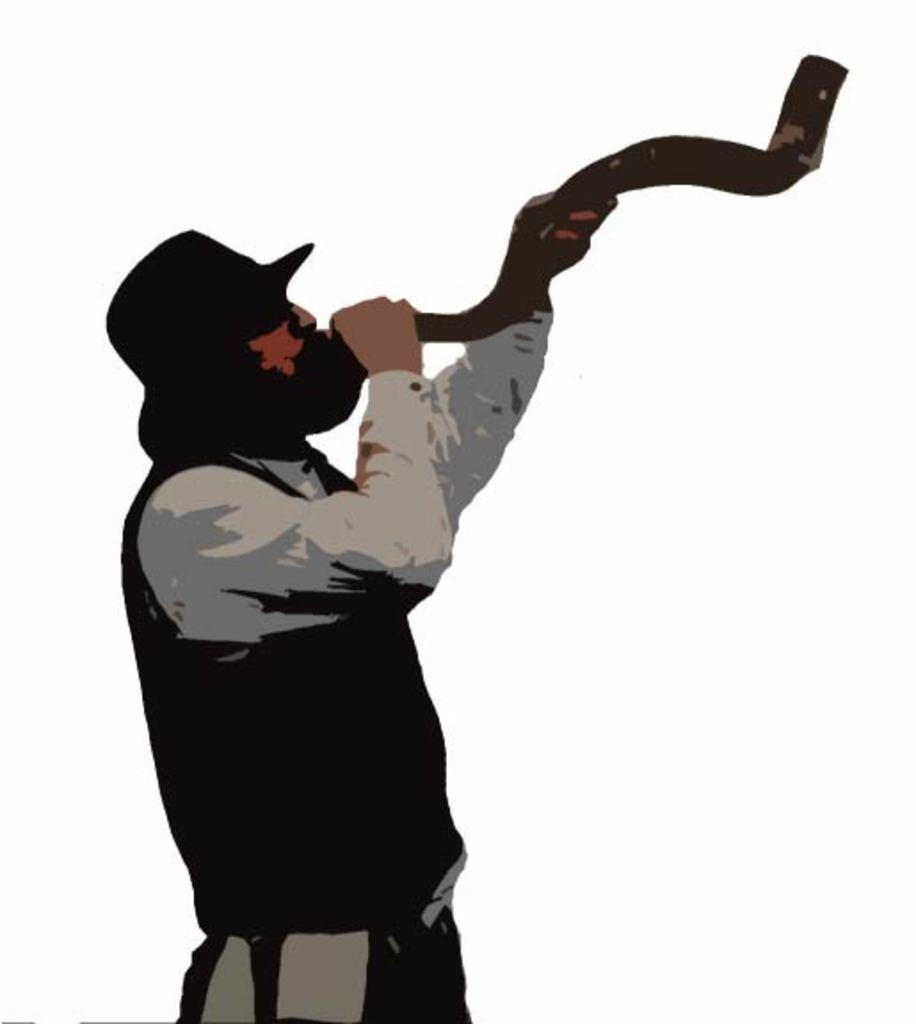Please provide a concise description of this image. In this image there is a depiction of a person holding some object in his hands. 